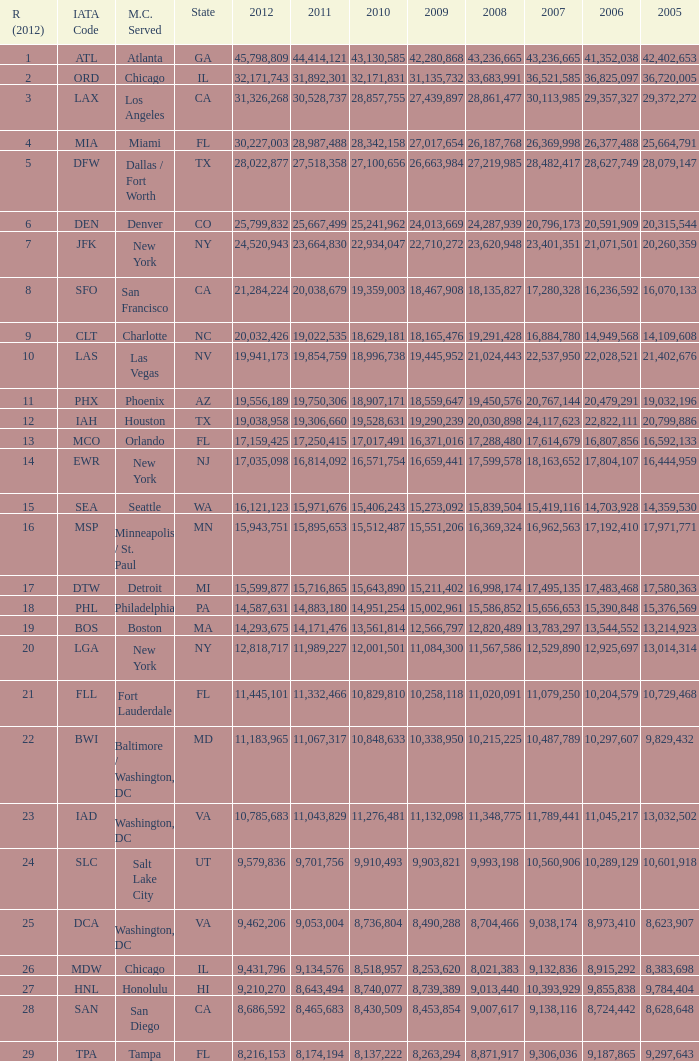When Philadelphia has a 2007 less than 20,796,173 and a 2008 more than 10,215,225, what is the smallest 2009? 15002961.0. 